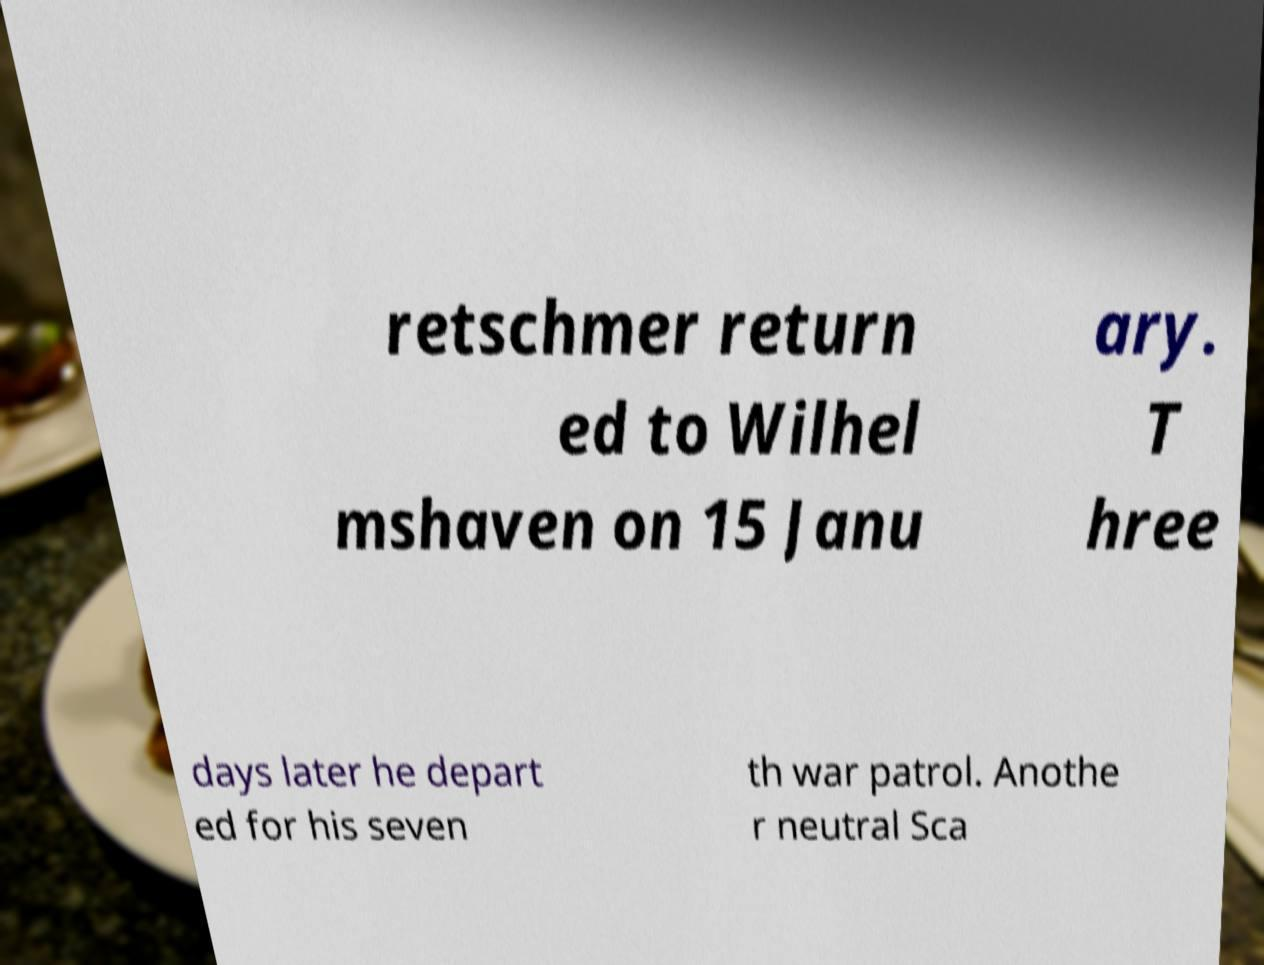Please identify and transcribe the text found in this image. retschmer return ed to Wilhel mshaven on 15 Janu ary. T hree days later he depart ed for his seven th war patrol. Anothe r neutral Sca 